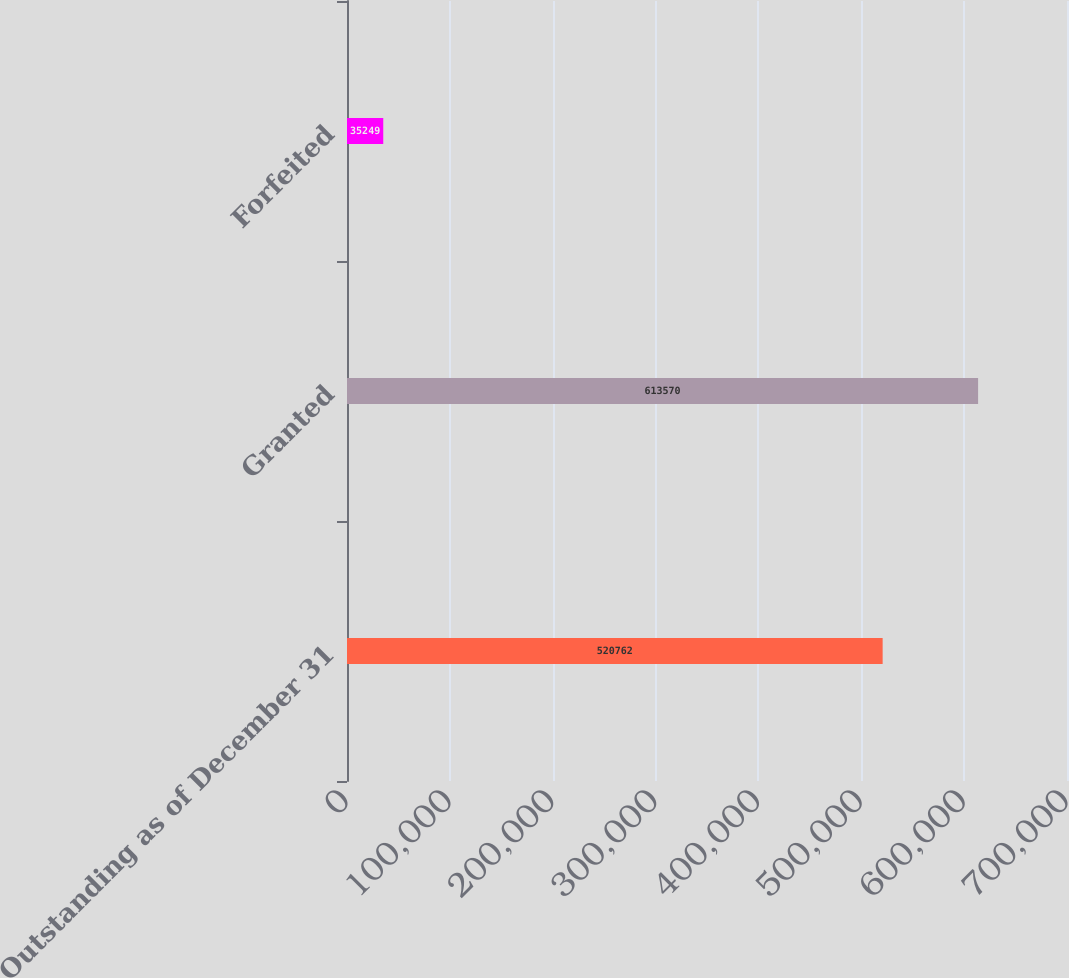Convert chart to OTSL. <chart><loc_0><loc_0><loc_500><loc_500><bar_chart><fcel>Outstanding as of December 31<fcel>Granted<fcel>Forfeited<nl><fcel>520762<fcel>613570<fcel>35249<nl></chart> 